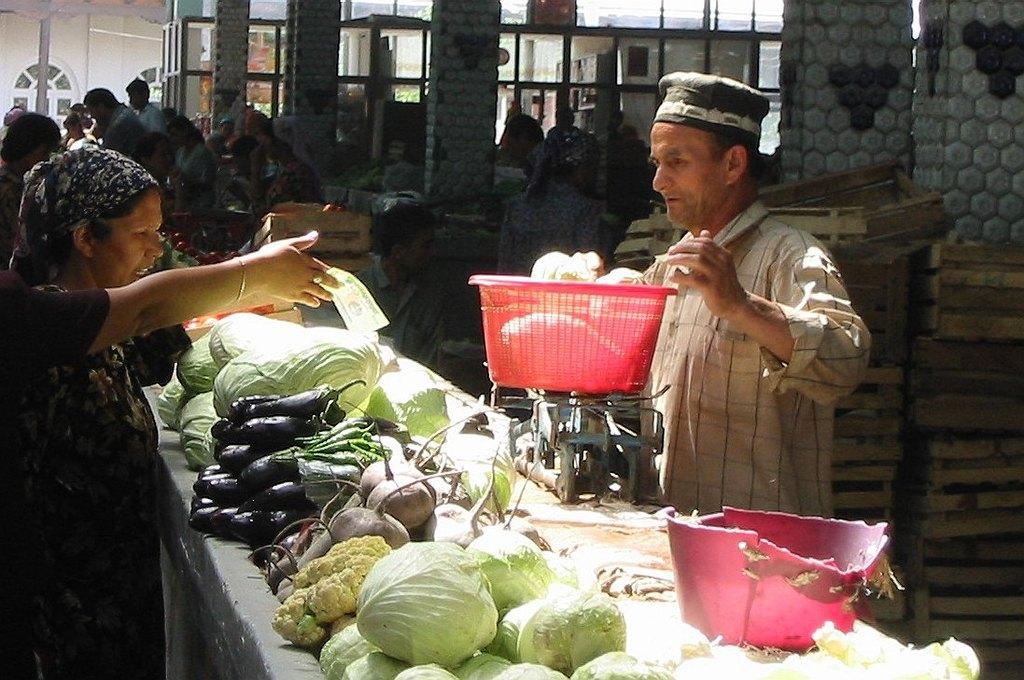In one or two sentences, can you explain what this image depicts? Here on the left we can see a person hand holding a currency note in the hand and there are few other persons standing and sitting on a platform. On the right a man is standing and weighing the food item in a basket on a weighing machine. There are different types of vegetables on a platform. In the background we can see pillars,windows,wall,few persons,wooden boxes and some other objects. 